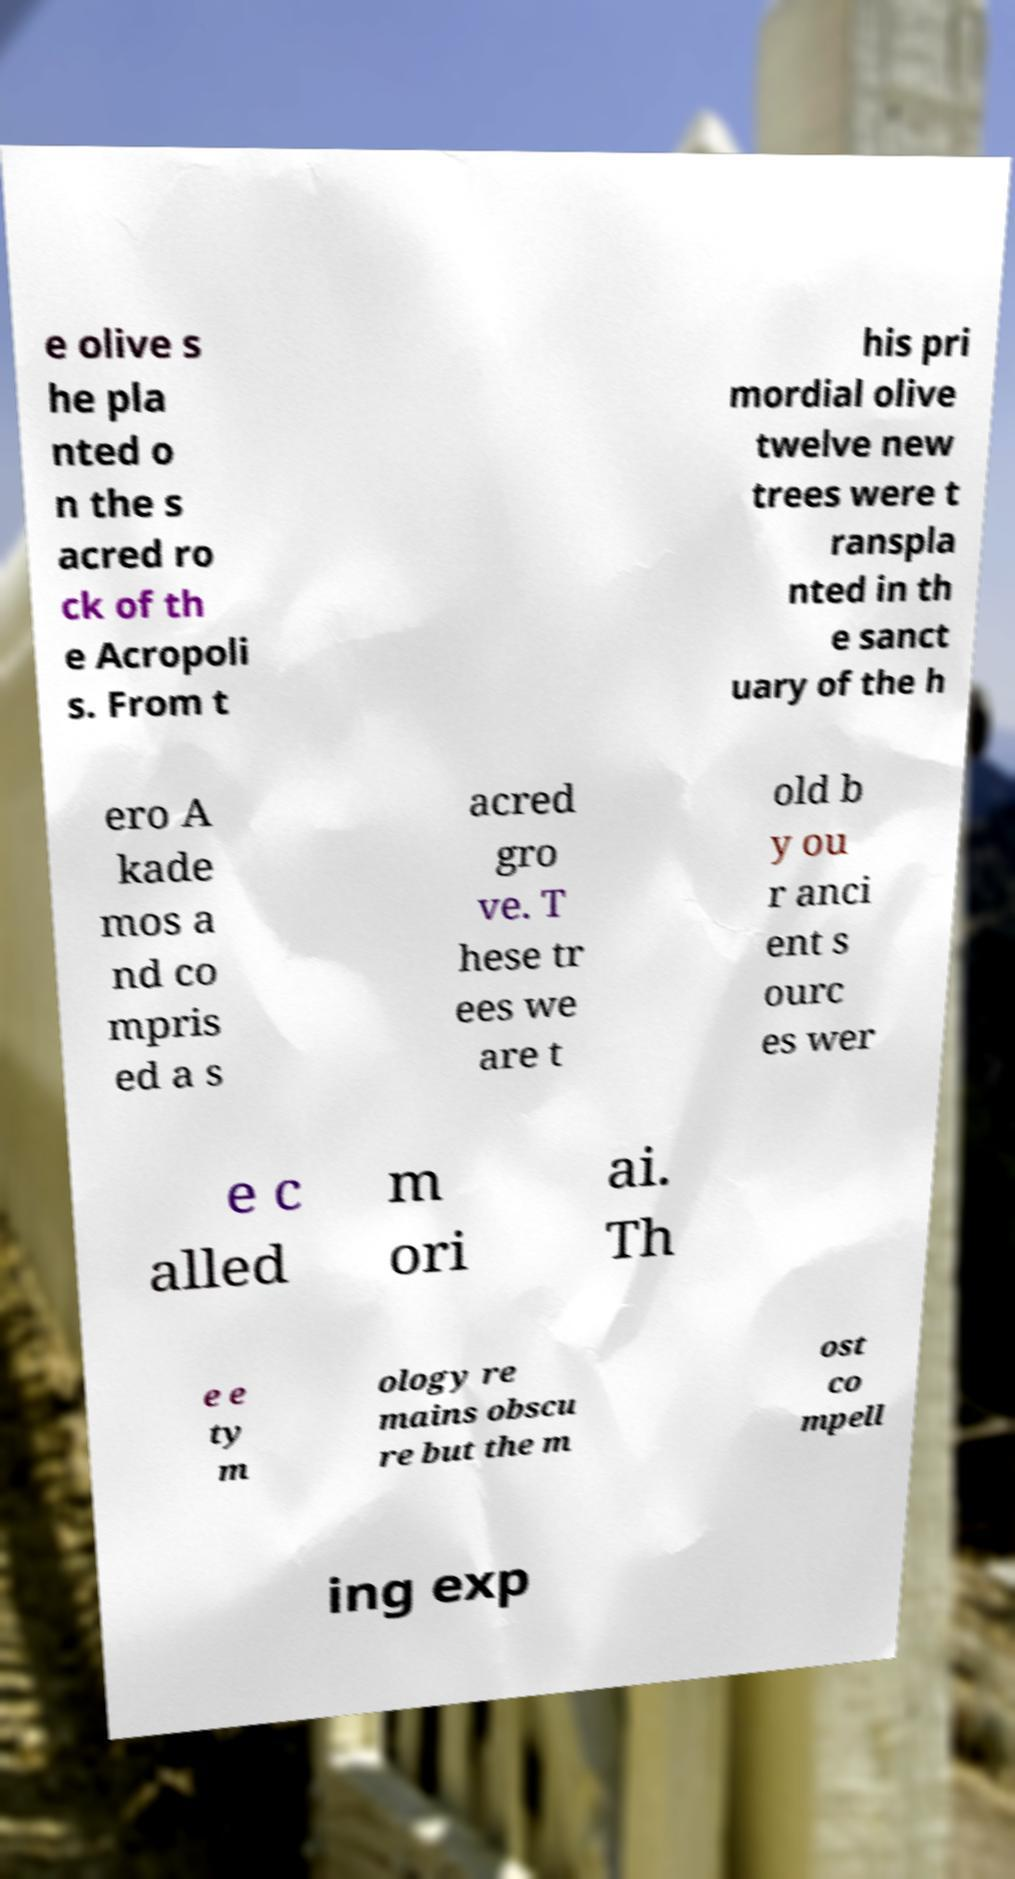What messages or text are displayed in this image? I need them in a readable, typed format. e olive s he pla nted o n the s acred ro ck of th e Acropoli s. From t his pri mordial olive twelve new trees were t ranspla nted in th e sanct uary of the h ero A kade mos a nd co mpris ed a s acred gro ve. T hese tr ees we are t old b y ou r anci ent s ourc es wer e c alled m ori ai. Th e e ty m ology re mains obscu re but the m ost co mpell ing exp 